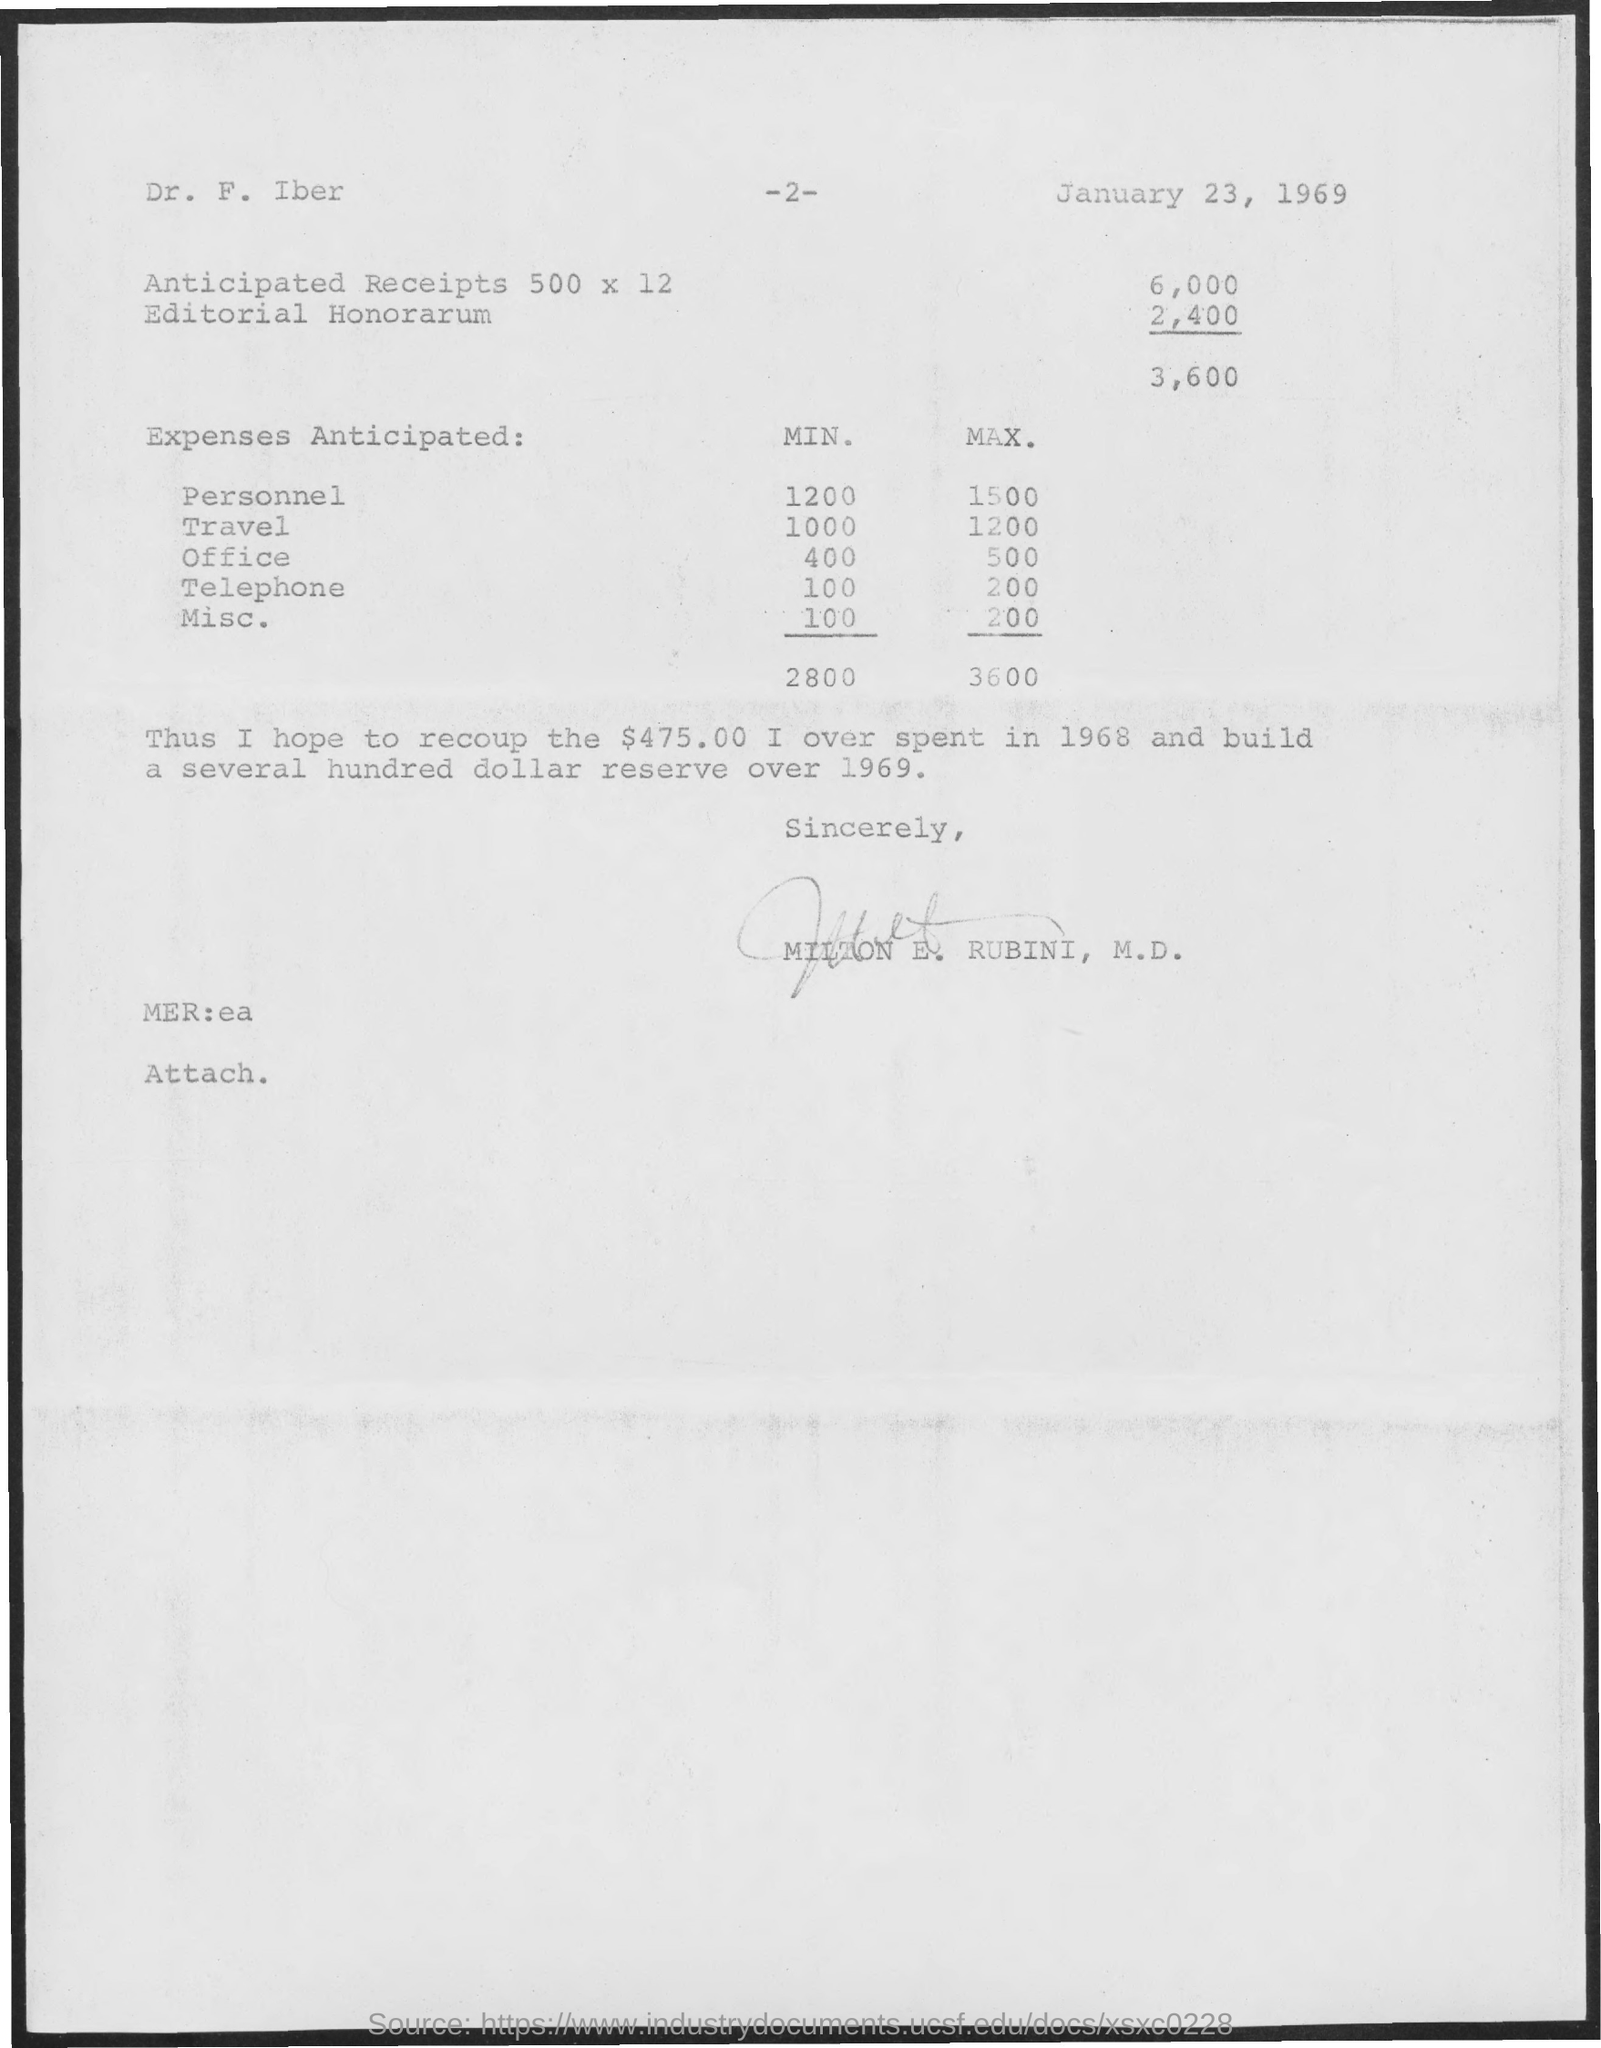Who has signed this document?
Your answer should be compact. MILTON E. RUBINI, M.D. What is the minimum personnel expense anticipated?
Your answer should be compact. 1200. What is the maximum travel expense anticipated?
Offer a very short reply. 1200. What is the minimum Misc. expense anticipated?
Provide a short and direct response. 100. 